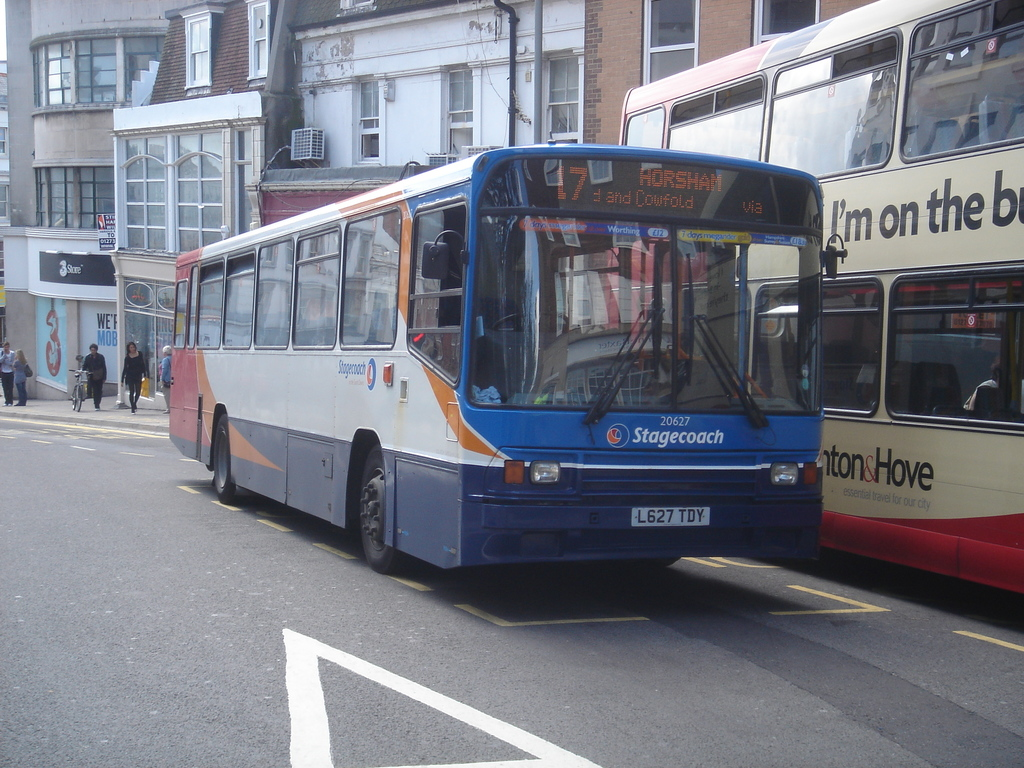Describe the surroundings visible in this image. The buses are operating in a commercial urban area, with various shops and a notable signage of 'Shore' in the background. Pedestrians can be seen on the sidewalks, emphasizing the everyday hustle and bustle typical of a city center environment. 